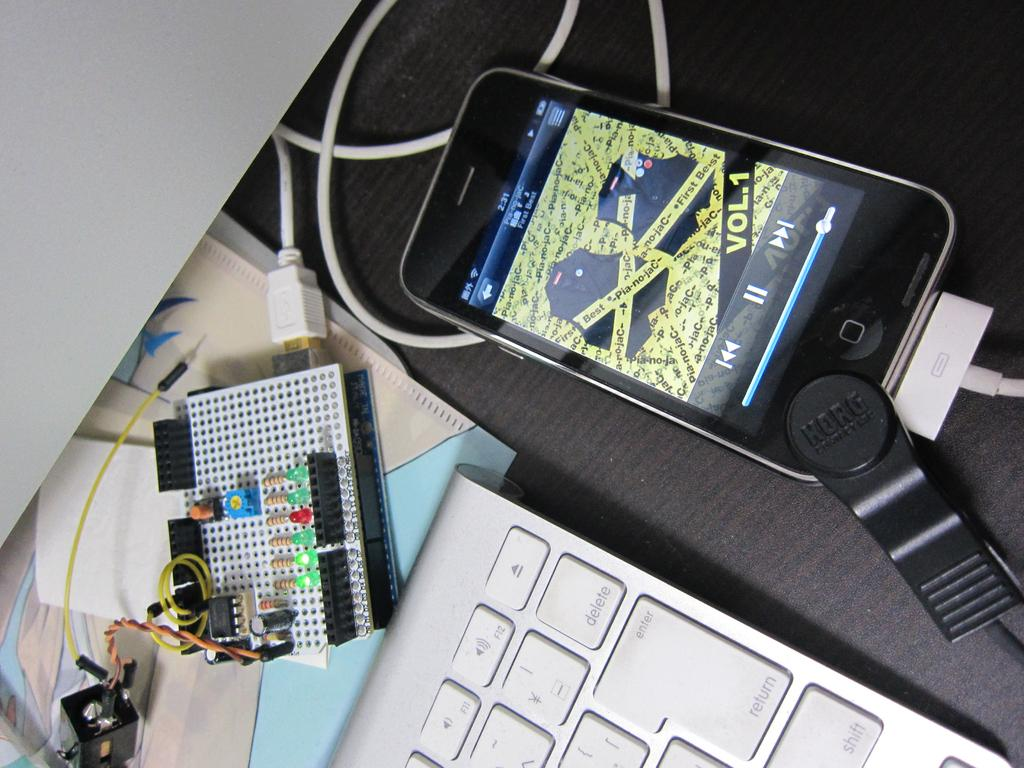What electronic device is visible in the image? There is a keyboard in the image. What other electronic device can be seen in the image? There is a mobile in the image. What type of board is present in the image? There is an electric board in the image. What type of material is present in the image? There are papers in the image. What is the color of the surface in the image? The surface in the image is grey in color. How many laborers are working on the shelf in the image? There is no shelf or laborers present in the image. What is the rate of the electric board in the image? The image does not provide information about the rate of the electric board. 